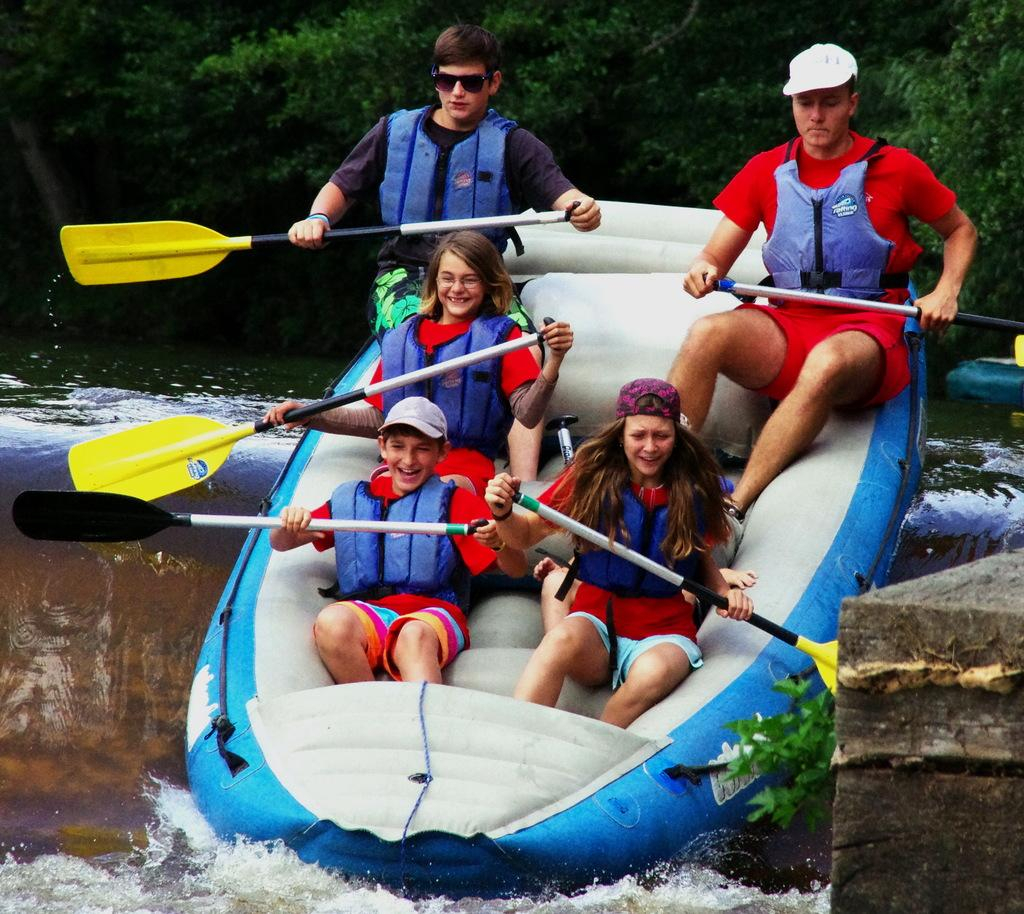What activity are the persons in the image engaged in? The persons in the image are rafting on the water. What are the persons using to navigate the water? The persons are holding paddles in their hands. What can be seen in the background of the image? There is water and trees visible in the background. What type of chin is visible on the raft in the image? There is no chin visible on the raft in the image, as a chin is a part of the human face and not a feature of a raft. 